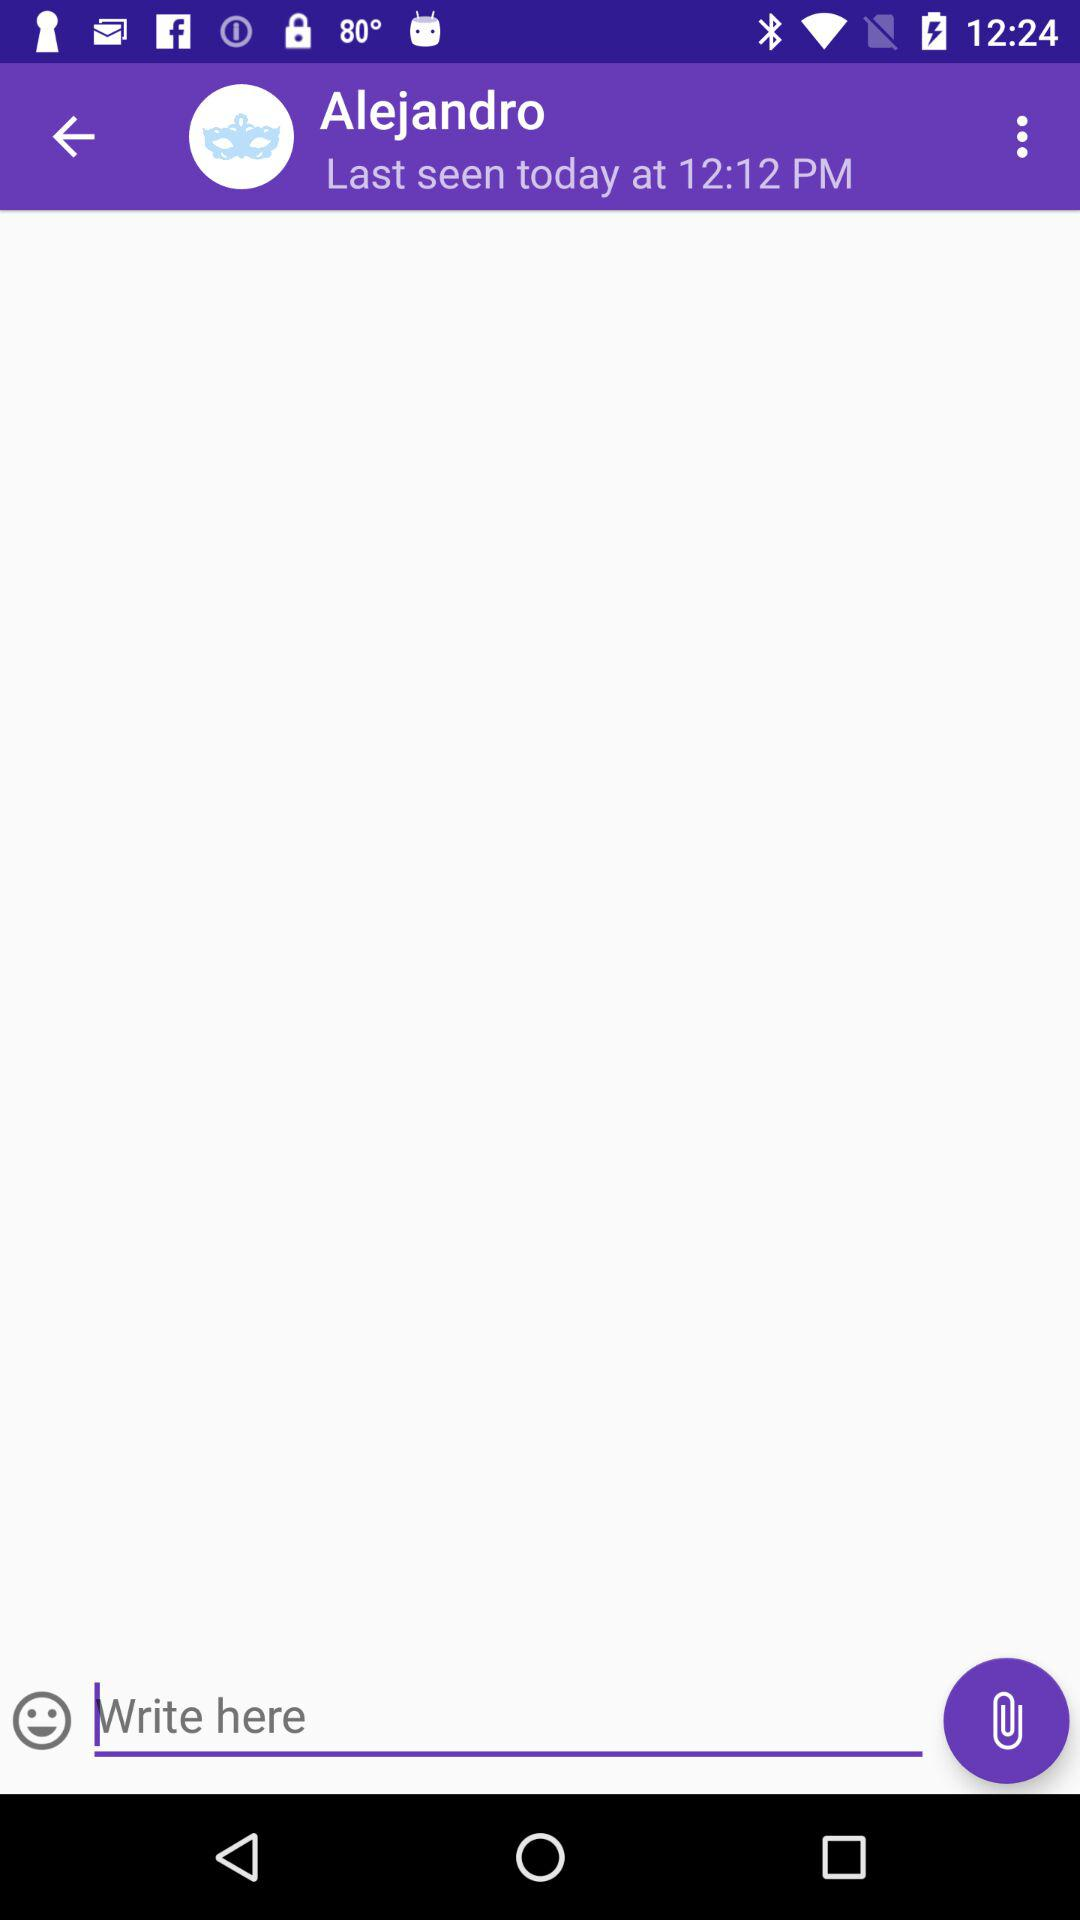When did the user create an account on this app?
When the provided information is insufficient, respond with <no answer>. <no answer> 